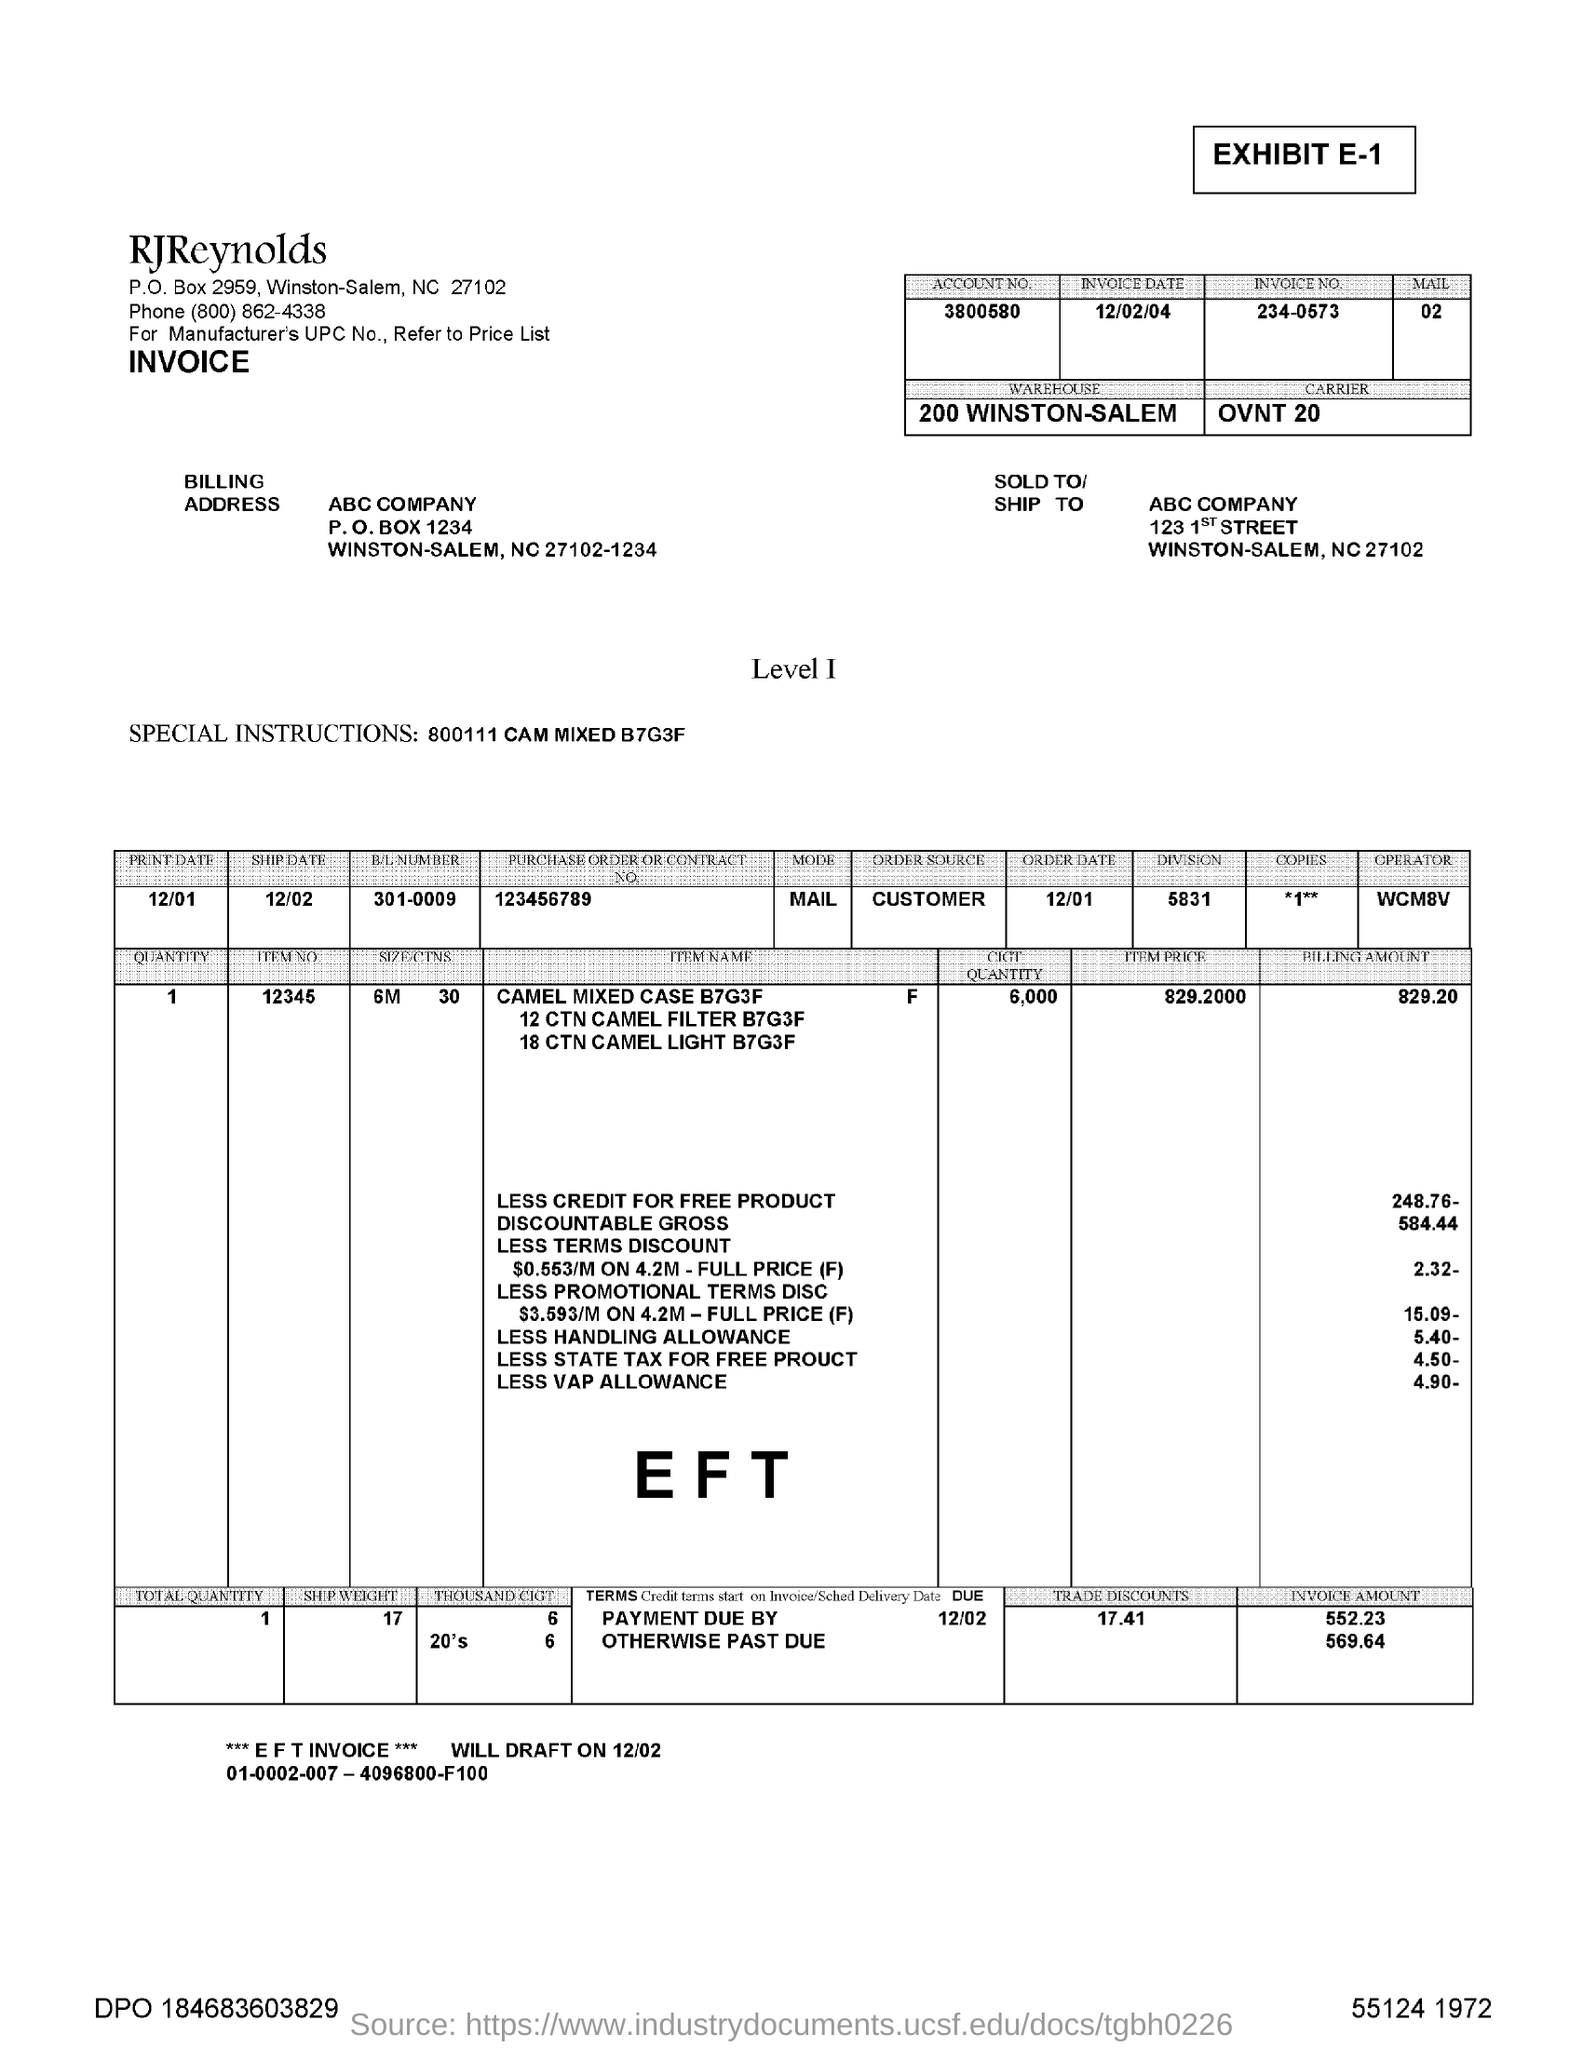Draw attention to some important aspects in this diagram. The invoice number is 234-0573. The B/L NUMBER is 301-0009. The ship date is on 12/02. The order source is the CUSTOMER. The special instructions are CAM MIXED B7G3F. 